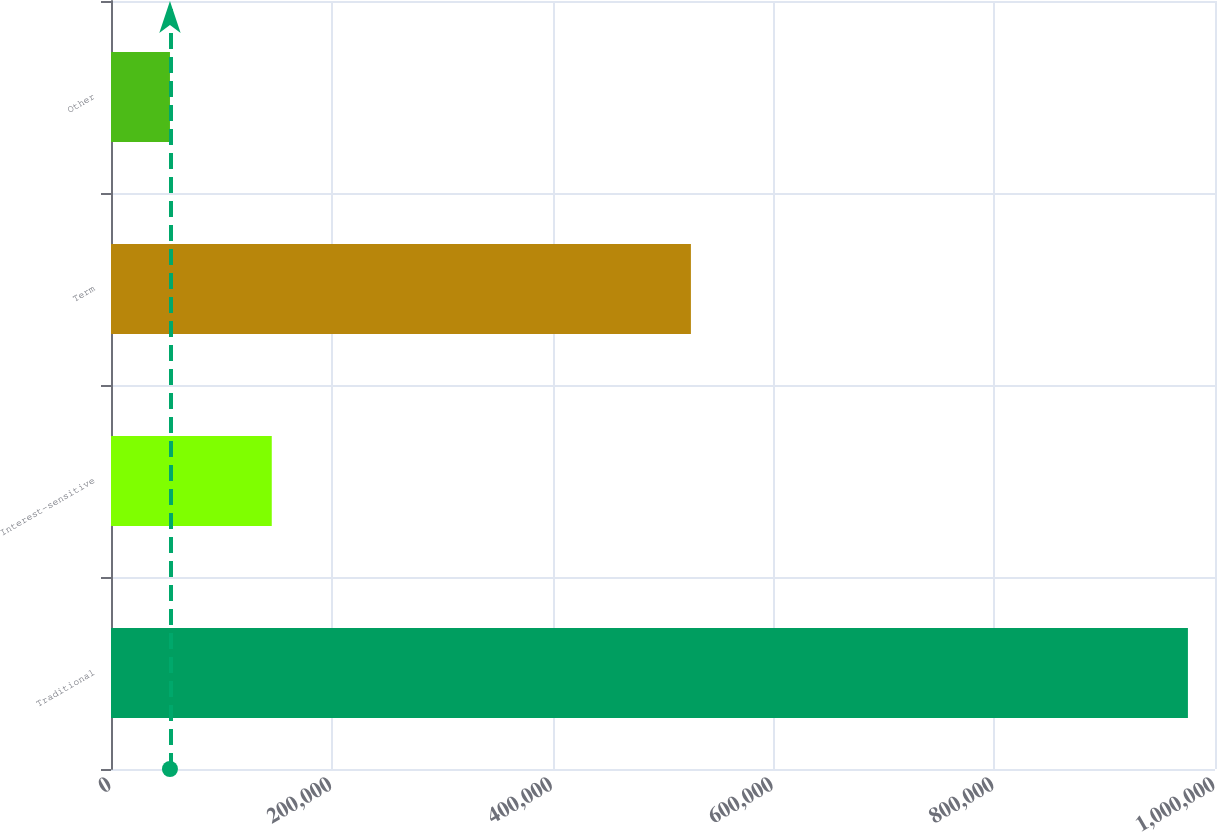<chart> <loc_0><loc_0><loc_500><loc_500><bar_chart><fcel>Traditional<fcel>Interest-sensitive<fcel>Term<fcel>Other<nl><fcel>975475<fcel>145616<fcel>525279<fcel>53410<nl></chart> 